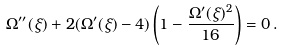Convert formula to latex. <formula><loc_0><loc_0><loc_500><loc_500>\Omega ^ { \prime \prime } ( \xi ) + 2 ( \Omega ^ { \prime } ( \xi ) - 4 ) \left ( 1 - \frac { \Omega ^ { \prime } ( \xi ) ^ { 2 } } { 1 6 } \right ) = 0 \, .</formula> 